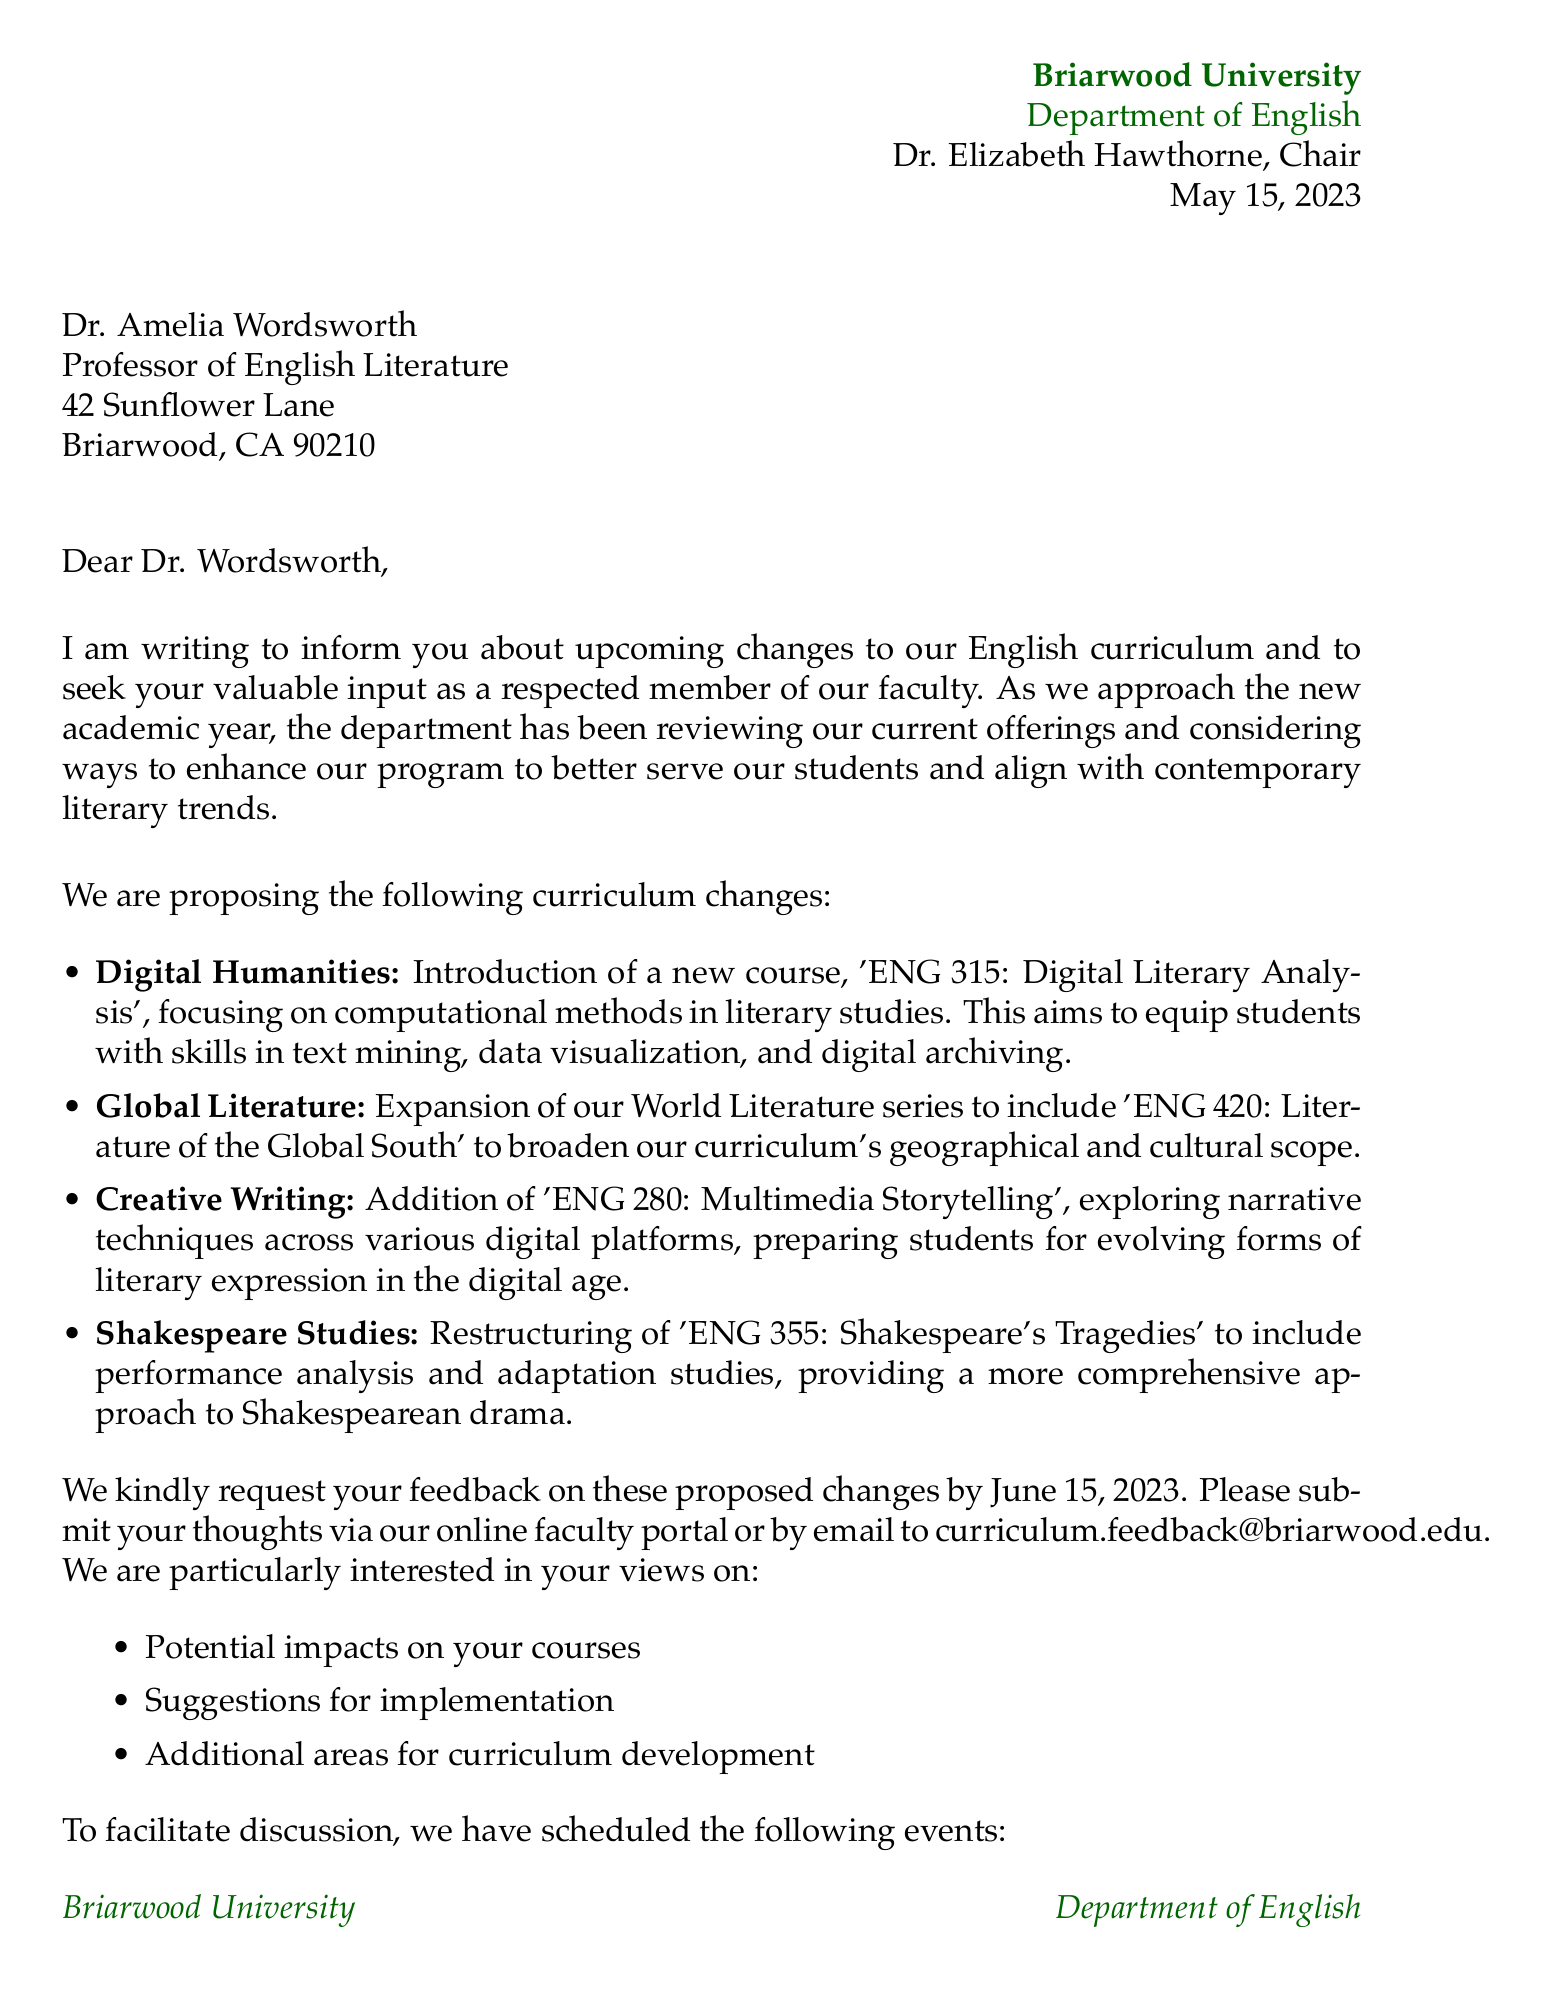What is the name of the university? The university's name is mentioned at the beginning of the document in the letter header.
Answer: Briarwood University Who is the chair of the Department of English? The chair's name is specified in the letter header as the individual who signed the letter.
Answer: Dr. Elizabeth Hawthorne What is the date of the letter? The date is provided in the letter header, indicating when the letter was written.
Answer: May 15, 2023 What is the deadline for submitting feedback? The deadline for feedback is explicitly stated in the section that requests input from the recipient.
Answer: June 15, 2023 What new course is being introduced in the Digital Humanities area? The specific new course title is mentioned in the curriculum changes section under Digital Humanities.
Answer: ENG 315: Digital Literary Analysis Which event is scheduled for May 30, 2023? The event date and name are provided in the upcoming events section of the letter.
Answer: Curriculum Town Hall What areas for feedback are mentioned in the letter? The letter lists specific areas where feedback is requested from the recipient.
Answer: Potential impacts on your courses, Suggestions for implementation, Additional areas for curriculum development What is the location of the Curriculum Town Hall? The location is detailed in the upcoming events section, providing context for the event.
Answer: Austen Auditorium, English Department Building Why is the course 'ENG 280: Multimedia Storytelling' added? The rationale is shared within the description of the proposed course in the curriculum changes.
Answer: To prepare students for evolving forms of literary expression in the digital age What kind of format is suggested for discussion of the proposed changes? The letter invites the recipient to consider how to discuss the proposed changes in her gatherings.
Answer: Backyard lectures 